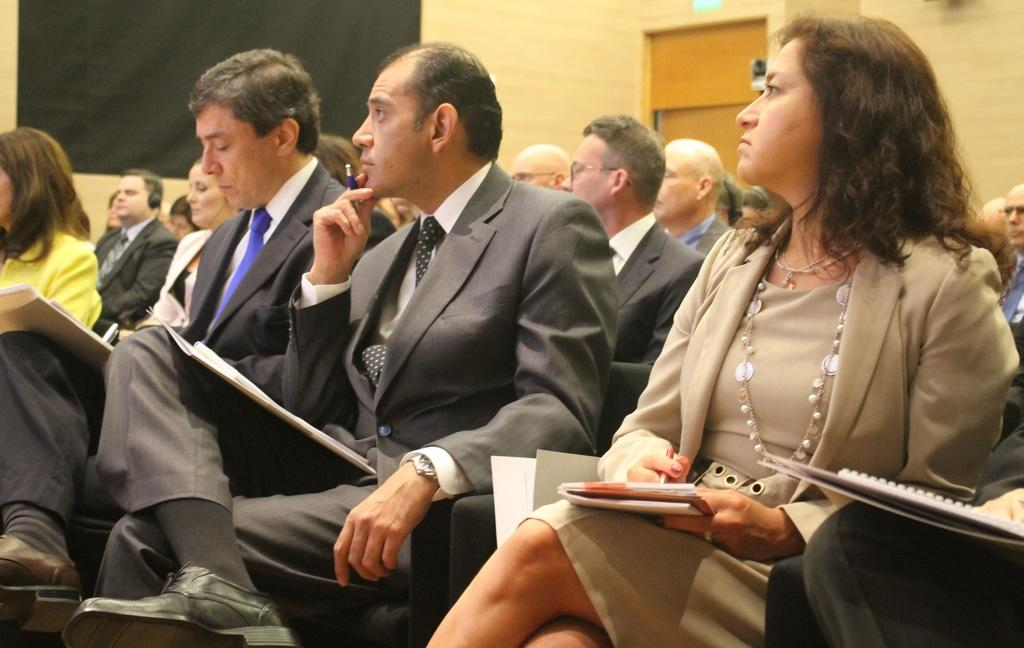What are the people in the image doing? The people in the image are sitting. Can you describe the woman on the right side of the image? The woman on the right side of the image is holding a book. What can be seen in the background of the image? There is a wall in the background of the image. What type of clothing are two of the persons wearing? Two persons are wearing suits. What type of screw can be seen in the woman's hand in the image? There is no screw present in the image; the woman is holding a book. What impulse might have caused the people to gather in the image? The provided facts do not indicate any specific reason or impulse for the people to gather in the image. 